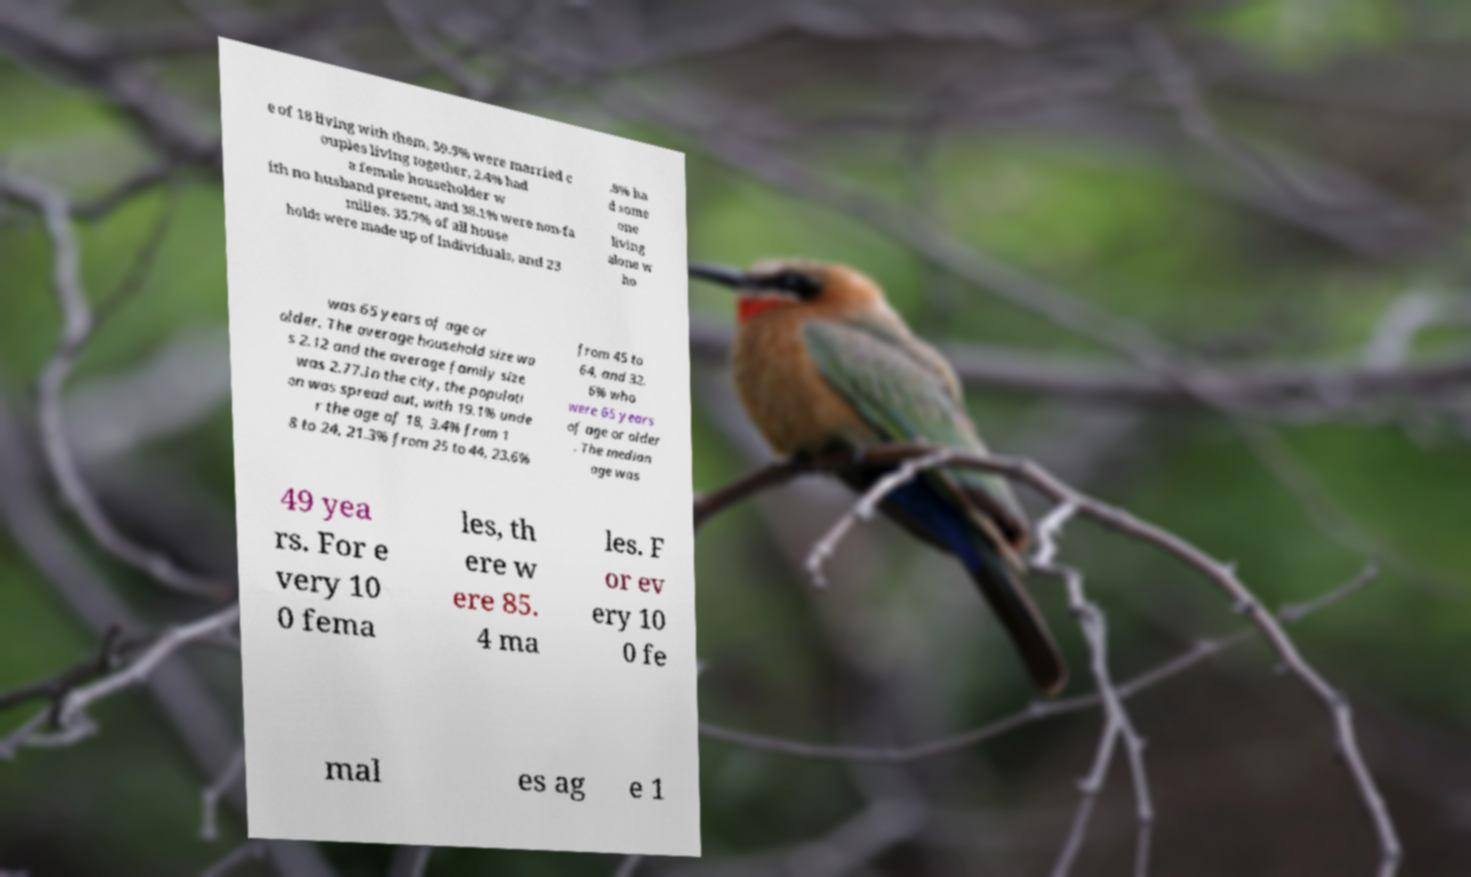For documentation purposes, I need the text within this image transcribed. Could you provide that? e of 18 living with them, 59.5% were married c ouples living together, 2.4% had a female householder w ith no husband present, and 38.1% were non-fa milies. 35.7% of all house holds were made up of individuals, and 23 .8% ha d some one living alone w ho was 65 years of age or older. The average household size wa s 2.12 and the average family size was 2.77.In the city, the populati on was spread out, with 19.1% unde r the age of 18, 3.4% from 1 8 to 24, 21.3% from 25 to 44, 23.6% from 45 to 64, and 32. 6% who were 65 years of age or older . The median age was 49 yea rs. For e very 10 0 fema les, th ere w ere 85. 4 ma les. F or ev ery 10 0 fe mal es ag e 1 